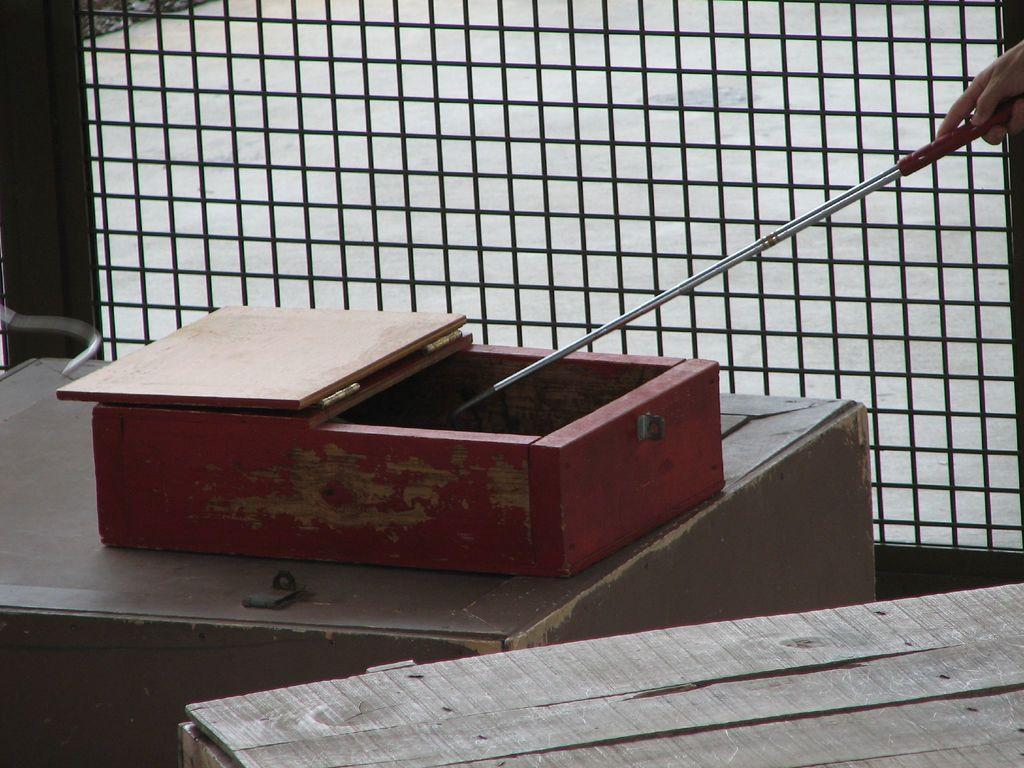Describe this image in one or two sentences. In this image here I can see a box and hand of a person. 